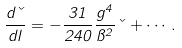<formula> <loc_0><loc_0><loc_500><loc_500>\frac { d \kappa } { d l } = - \frac { 3 1 } { 2 4 0 } \frac { g ^ { 4 } } { \pi ^ { 2 } } \kappa + \cdots .</formula> 